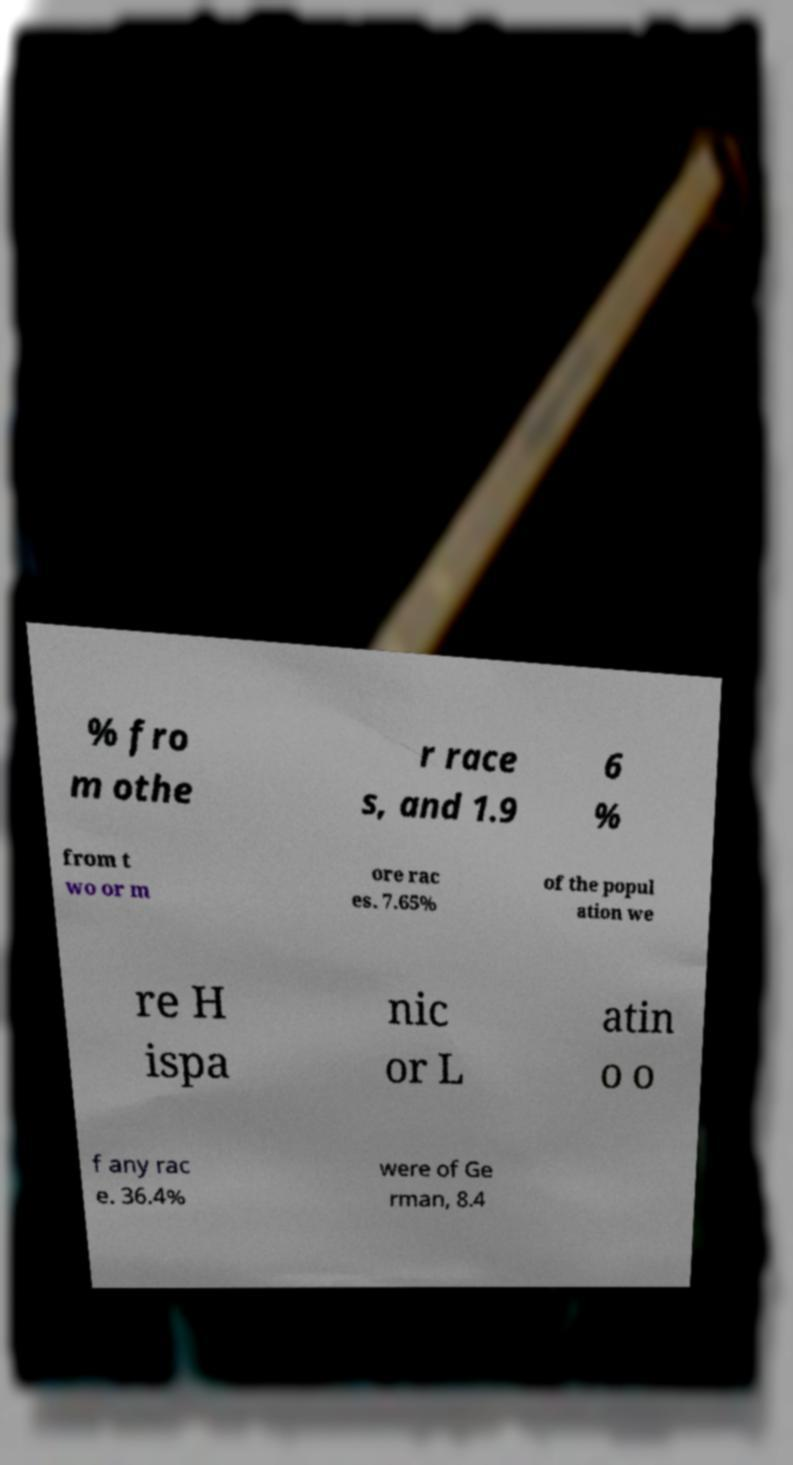Please read and relay the text visible in this image. What does it say? % fro m othe r race s, and 1.9 6 % from t wo or m ore rac es. 7.65% of the popul ation we re H ispa nic or L atin o o f any rac e. 36.4% were of Ge rman, 8.4 